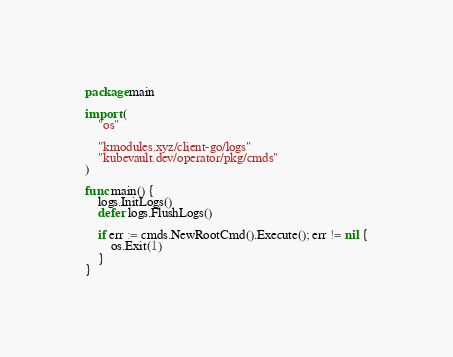<code> <loc_0><loc_0><loc_500><loc_500><_Go_>package main

import (
	"os"

	"kmodules.xyz/client-go/logs"
	"kubevault.dev/operator/pkg/cmds"
)

func main() {
	logs.InitLogs()
	defer logs.FlushLogs()

	if err := cmds.NewRootCmd().Execute(); err != nil {
		os.Exit(1)
	}
}
</code> 